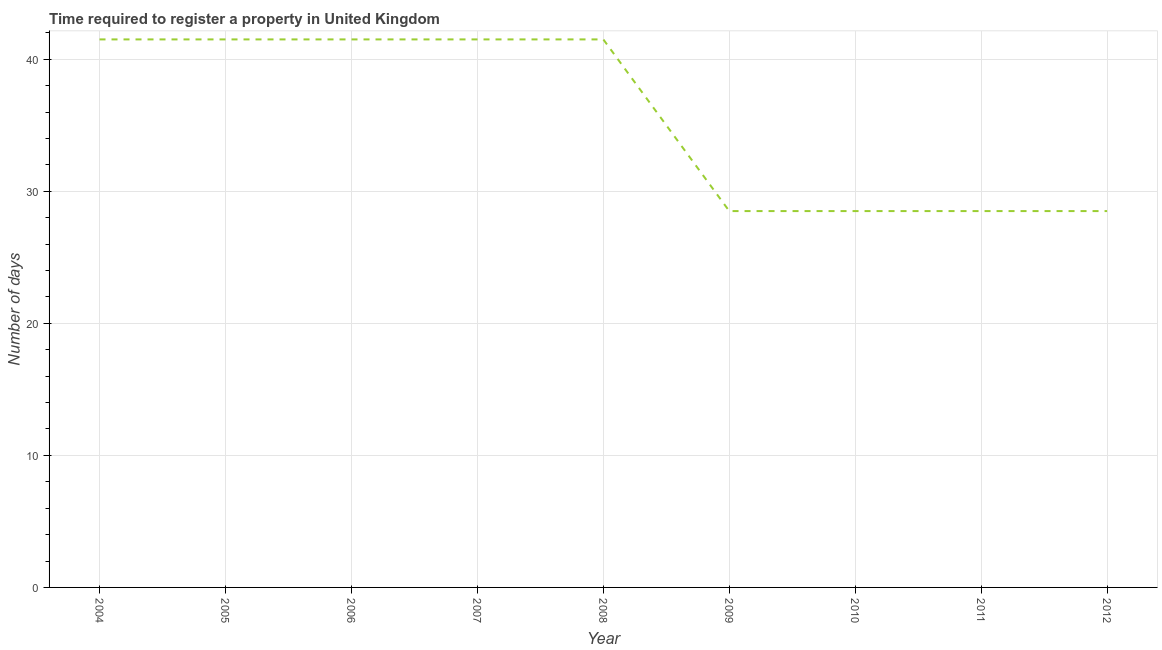Across all years, what is the maximum number of days required to register property?
Ensure brevity in your answer.  41.5. Across all years, what is the minimum number of days required to register property?
Your answer should be very brief. 28.5. In which year was the number of days required to register property maximum?
Ensure brevity in your answer.  2004. What is the sum of the number of days required to register property?
Provide a short and direct response. 321.5. What is the difference between the number of days required to register property in 2005 and 2009?
Make the answer very short. 13. What is the average number of days required to register property per year?
Your answer should be compact. 35.72. What is the median number of days required to register property?
Offer a terse response. 41.5. In how many years, is the number of days required to register property greater than 24 days?
Provide a short and direct response. 9. Do a majority of the years between 2006 and 2005 (inclusive) have number of days required to register property greater than 24 days?
Keep it short and to the point. No. What is the ratio of the number of days required to register property in 2008 to that in 2009?
Give a very brief answer. 1.46. What is the difference between the highest and the second highest number of days required to register property?
Offer a very short reply. 0. In how many years, is the number of days required to register property greater than the average number of days required to register property taken over all years?
Ensure brevity in your answer.  5. How many years are there in the graph?
Keep it short and to the point. 9. Does the graph contain grids?
Offer a very short reply. Yes. What is the title of the graph?
Your response must be concise. Time required to register a property in United Kingdom. What is the label or title of the Y-axis?
Offer a terse response. Number of days. What is the Number of days in 2004?
Keep it short and to the point. 41.5. What is the Number of days in 2005?
Make the answer very short. 41.5. What is the Number of days of 2006?
Offer a terse response. 41.5. What is the Number of days of 2007?
Your answer should be compact. 41.5. What is the Number of days of 2008?
Ensure brevity in your answer.  41.5. What is the Number of days of 2010?
Ensure brevity in your answer.  28.5. What is the Number of days of 2012?
Your answer should be compact. 28.5. What is the difference between the Number of days in 2004 and 2005?
Give a very brief answer. 0. What is the difference between the Number of days in 2004 and 2008?
Your answer should be very brief. 0. What is the difference between the Number of days in 2004 and 2010?
Your answer should be very brief. 13. What is the difference between the Number of days in 2004 and 2012?
Make the answer very short. 13. What is the difference between the Number of days in 2005 and 2009?
Ensure brevity in your answer.  13. What is the difference between the Number of days in 2005 and 2010?
Give a very brief answer. 13. What is the difference between the Number of days in 2005 and 2011?
Make the answer very short. 13. What is the difference between the Number of days in 2005 and 2012?
Ensure brevity in your answer.  13. What is the difference between the Number of days in 2006 and 2008?
Ensure brevity in your answer.  0. What is the difference between the Number of days in 2006 and 2009?
Ensure brevity in your answer.  13. What is the difference between the Number of days in 2006 and 2012?
Keep it short and to the point. 13. What is the difference between the Number of days in 2007 and 2008?
Your answer should be compact. 0. What is the difference between the Number of days in 2007 and 2009?
Your answer should be very brief. 13. What is the difference between the Number of days in 2007 and 2010?
Your answer should be compact. 13. What is the difference between the Number of days in 2007 and 2011?
Your response must be concise. 13. What is the difference between the Number of days in 2008 and 2011?
Provide a succinct answer. 13. What is the difference between the Number of days in 2008 and 2012?
Offer a very short reply. 13. What is the difference between the Number of days in 2011 and 2012?
Provide a short and direct response. 0. What is the ratio of the Number of days in 2004 to that in 2009?
Ensure brevity in your answer.  1.46. What is the ratio of the Number of days in 2004 to that in 2010?
Offer a terse response. 1.46. What is the ratio of the Number of days in 2004 to that in 2011?
Keep it short and to the point. 1.46. What is the ratio of the Number of days in 2004 to that in 2012?
Offer a very short reply. 1.46. What is the ratio of the Number of days in 2005 to that in 2008?
Your answer should be compact. 1. What is the ratio of the Number of days in 2005 to that in 2009?
Give a very brief answer. 1.46. What is the ratio of the Number of days in 2005 to that in 2010?
Offer a very short reply. 1.46. What is the ratio of the Number of days in 2005 to that in 2011?
Make the answer very short. 1.46. What is the ratio of the Number of days in 2005 to that in 2012?
Give a very brief answer. 1.46. What is the ratio of the Number of days in 2006 to that in 2007?
Your answer should be very brief. 1. What is the ratio of the Number of days in 2006 to that in 2009?
Provide a succinct answer. 1.46. What is the ratio of the Number of days in 2006 to that in 2010?
Your response must be concise. 1.46. What is the ratio of the Number of days in 2006 to that in 2011?
Your response must be concise. 1.46. What is the ratio of the Number of days in 2006 to that in 2012?
Your answer should be compact. 1.46. What is the ratio of the Number of days in 2007 to that in 2008?
Ensure brevity in your answer.  1. What is the ratio of the Number of days in 2007 to that in 2009?
Provide a short and direct response. 1.46. What is the ratio of the Number of days in 2007 to that in 2010?
Your response must be concise. 1.46. What is the ratio of the Number of days in 2007 to that in 2011?
Your response must be concise. 1.46. What is the ratio of the Number of days in 2007 to that in 2012?
Provide a succinct answer. 1.46. What is the ratio of the Number of days in 2008 to that in 2009?
Make the answer very short. 1.46. What is the ratio of the Number of days in 2008 to that in 2010?
Keep it short and to the point. 1.46. What is the ratio of the Number of days in 2008 to that in 2011?
Your response must be concise. 1.46. What is the ratio of the Number of days in 2008 to that in 2012?
Provide a short and direct response. 1.46. What is the ratio of the Number of days in 2009 to that in 2011?
Ensure brevity in your answer.  1. What is the ratio of the Number of days in 2010 to that in 2011?
Provide a short and direct response. 1. What is the ratio of the Number of days in 2010 to that in 2012?
Make the answer very short. 1. 